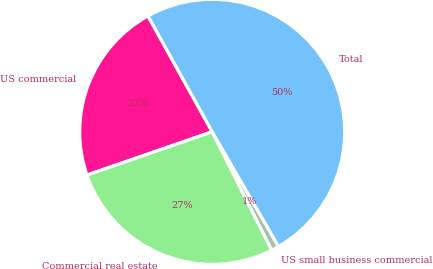Convert chart. <chart><loc_0><loc_0><loc_500><loc_500><pie_chart><fcel>US commercial<fcel>Commercial real estate<fcel>US small business commercial<fcel>Total<nl><fcel>22.24%<fcel>27.12%<fcel>0.93%<fcel>49.71%<nl></chart> 